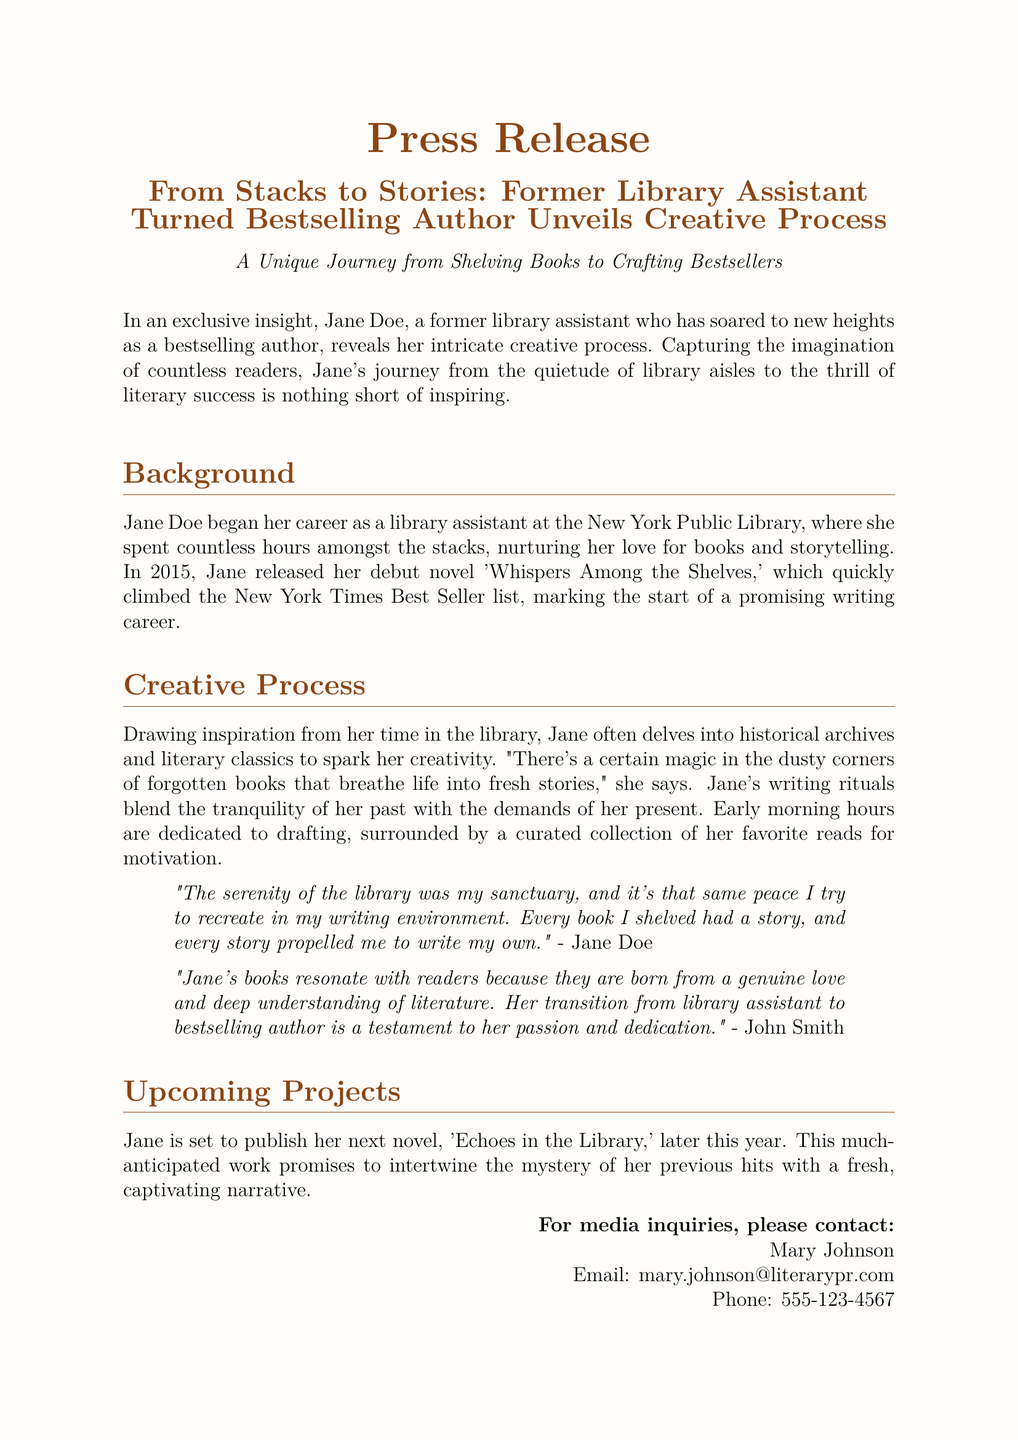What is the author's name? The author's name is mentioned at the beginning of the document.
Answer: Jane Doe What was Jane's debut novel? The debut novel released by Jane is stated in the background section of the document.
Answer: Whispers Among the Shelves In which year did Jane release her debut novel? The year of the debut novel's release is specified in the background section of the document.
Answer: 2015 What is the title of Jane's upcoming novel? The upcoming novel's title is mentioned in the section about upcoming projects.
Answer: Echoes in the Library What profession did Jane have before becoming an author? The document indicates Jane's previous profession near the beginning.
Answer: Library assistant Which library did Jane work at? The specific library where Jane worked is provided in the background section.
Answer: New York Public Library What is Jane's writing environment inspired by? The creative process section describes Jane’s inspiration for her writing environment.
Answer: Serenity of the library Who provided a quote about Jane's transition to bestselling author? The name of the individual who commented on Jane's transition is located in the document.
Answer: John Smith 